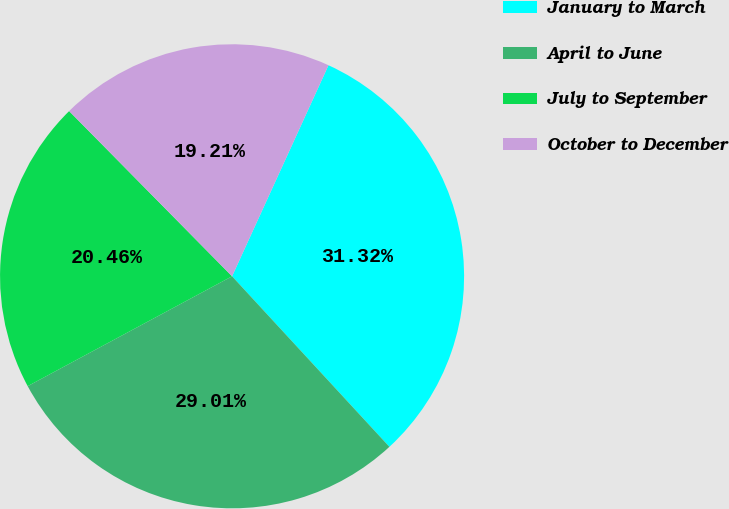Convert chart to OTSL. <chart><loc_0><loc_0><loc_500><loc_500><pie_chart><fcel>January to March<fcel>April to June<fcel>July to September<fcel>October to December<nl><fcel>31.32%<fcel>29.01%<fcel>20.46%<fcel>19.21%<nl></chart> 